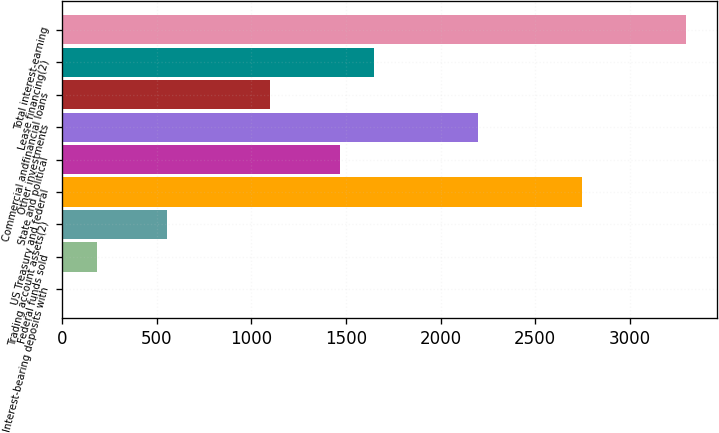Convert chart to OTSL. <chart><loc_0><loc_0><loc_500><loc_500><bar_chart><fcel>Interest-bearing deposits with<fcel>Federal funds sold<fcel>Trading account assets(2)<fcel>US Treasury and federal<fcel>State and political<fcel>Other investments<fcel>Commercial andfinancial loans<fcel>Lease financing(2)<fcel>Total interest-earning<nl><fcel>2<fcel>185<fcel>551<fcel>2747<fcel>1466<fcel>2198<fcel>1100<fcel>1649<fcel>3296<nl></chart> 